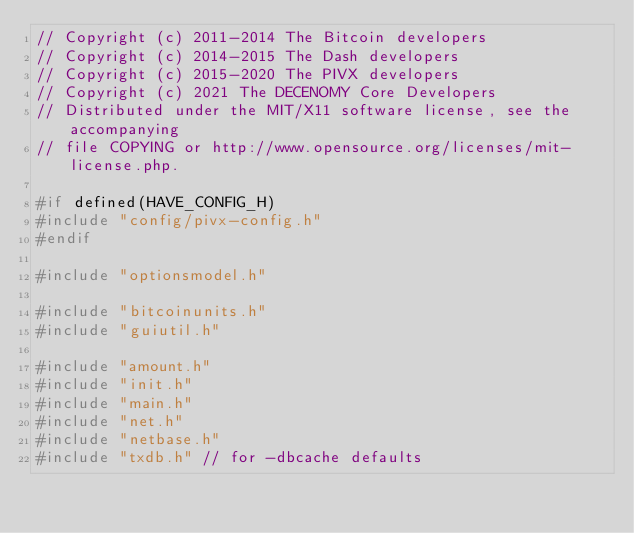<code> <loc_0><loc_0><loc_500><loc_500><_C++_>// Copyright (c) 2011-2014 The Bitcoin developers
// Copyright (c) 2014-2015 The Dash developers
// Copyright (c) 2015-2020 The PIVX developers
// Copyright (c) 2021 The DECENOMY Core Developers
// Distributed under the MIT/X11 software license, see the accompanying
// file COPYING or http://www.opensource.org/licenses/mit-license.php.

#if defined(HAVE_CONFIG_H)
#include "config/pivx-config.h"
#endif

#include "optionsmodel.h"

#include "bitcoinunits.h"
#include "guiutil.h"

#include "amount.h"
#include "init.h"
#include "main.h"
#include "net.h"
#include "netbase.h"
#include "txdb.h" // for -dbcache defaults</code> 